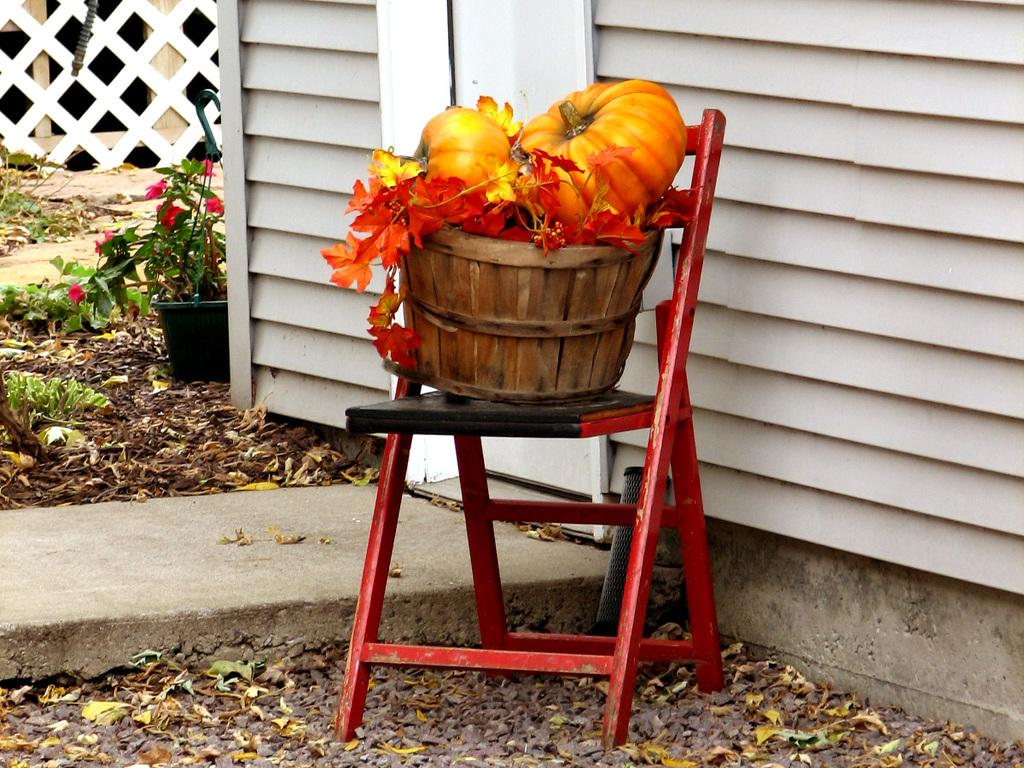What is on the table in the image? There is a basket on the table in the image. What is inside the basket? The basket contains pumpkins. What can be seen in the background of the image? There is a wall, a flower pot, and a fence in the background of the image. What type of branch is the grandfather holding in the image? There is no grandfather or branch present in the image. Can you describe the teeth of the person in the image? There is no person present in the image, so it is not possible to describe their teeth. 